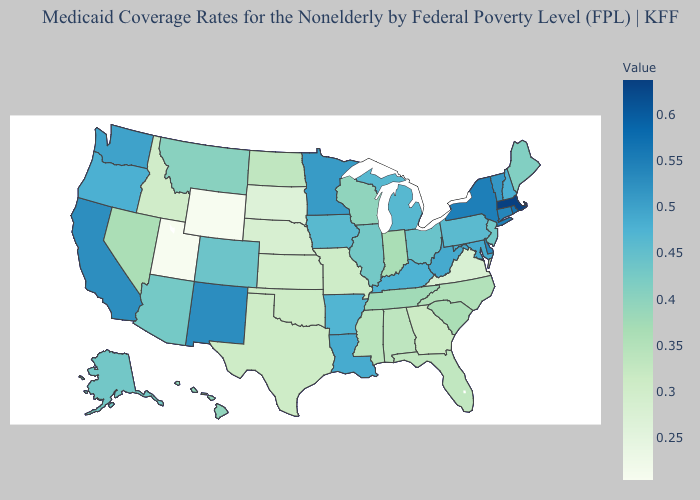Does Illinois have a lower value than West Virginia?
Answer briefly. Yes. Does Florida have the lowest value in the USA?
Keep it brief. No. Which states have the lowest value in the USA?
Concise answer only. Utah. Among the states that border Tennessee , does Virginia have the lowest value?
Answer briefly. Yes. Does Kentucky have a higher value than Montana?
Answer briefly. Yes. Does Montana have a higher value than Kentucky?
Write a very short answer. No. 